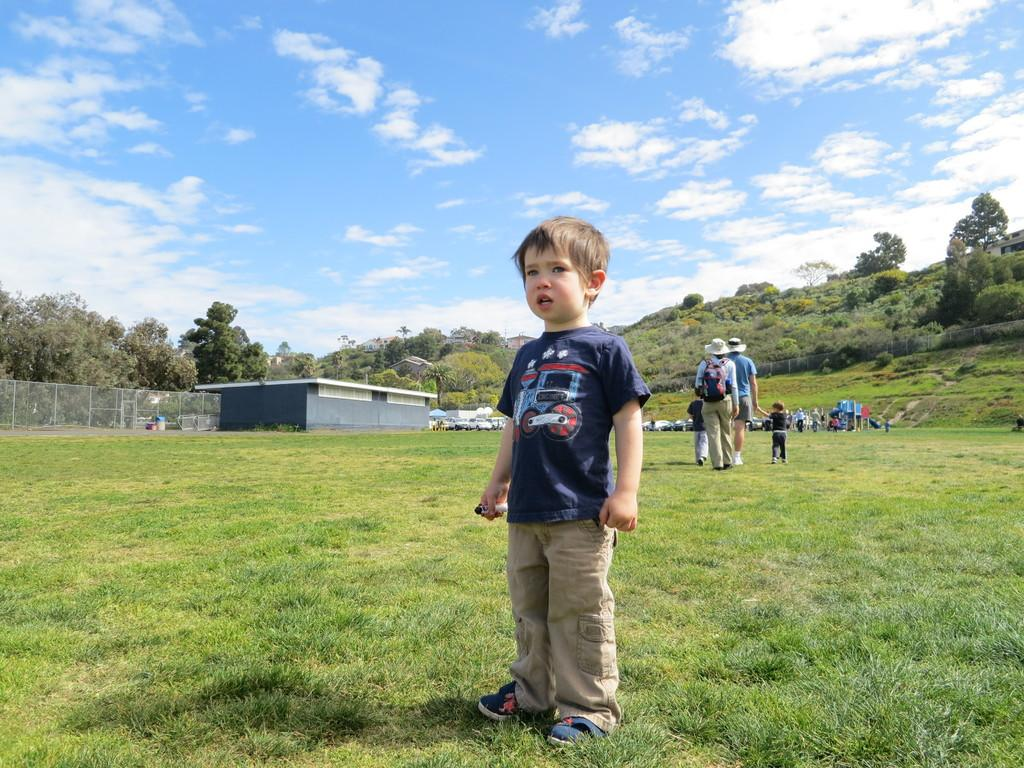What can be seen on the ground in the image? There are people on the ground in the image. What type of vegetation is present in the image? There are trees in the image. What type of structures are visible in the image? There are buildings in the image. What type of terrain is visible in the image? There is grass in the image. What type of transportation is present in the image? There are vehicles in the image. What is visible in the background of the image? The sky is visible in the background of the image. What can be seen in the sky in the image? Clouds are present in the sky. Can you hear the horn of the vehicle in the image? There is no sound present in the image, so it is not possible to hear any horn. What type of trail is visible in the image? There is no trail present in the image; it features people, trees, buildings, grass, vehicles, and a sky with clouds. 